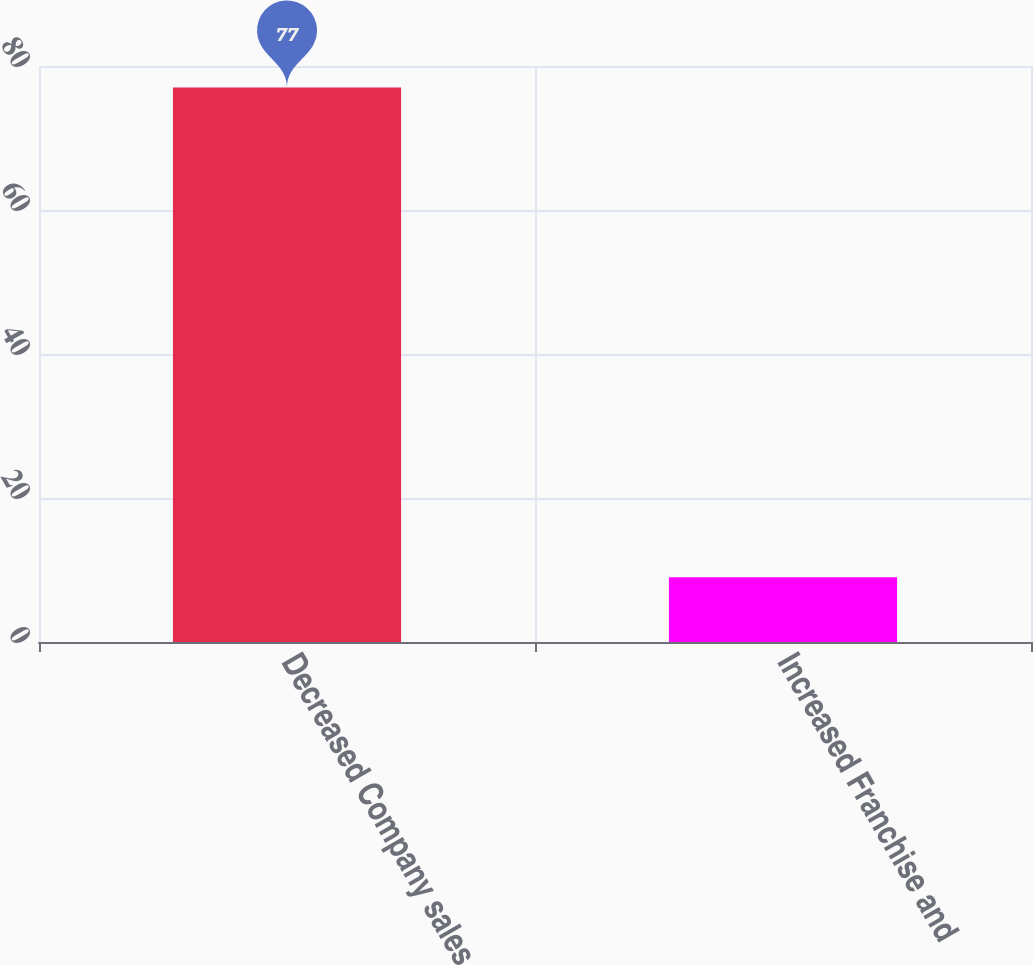Convert chart. <chart><loc_0><loc_0><loc_500><loc_500><bar_chart><fcel>Decreased Company sales<fcel>Increased Franchise and<nl><fcel>77<fcel>9<nl></chart> 